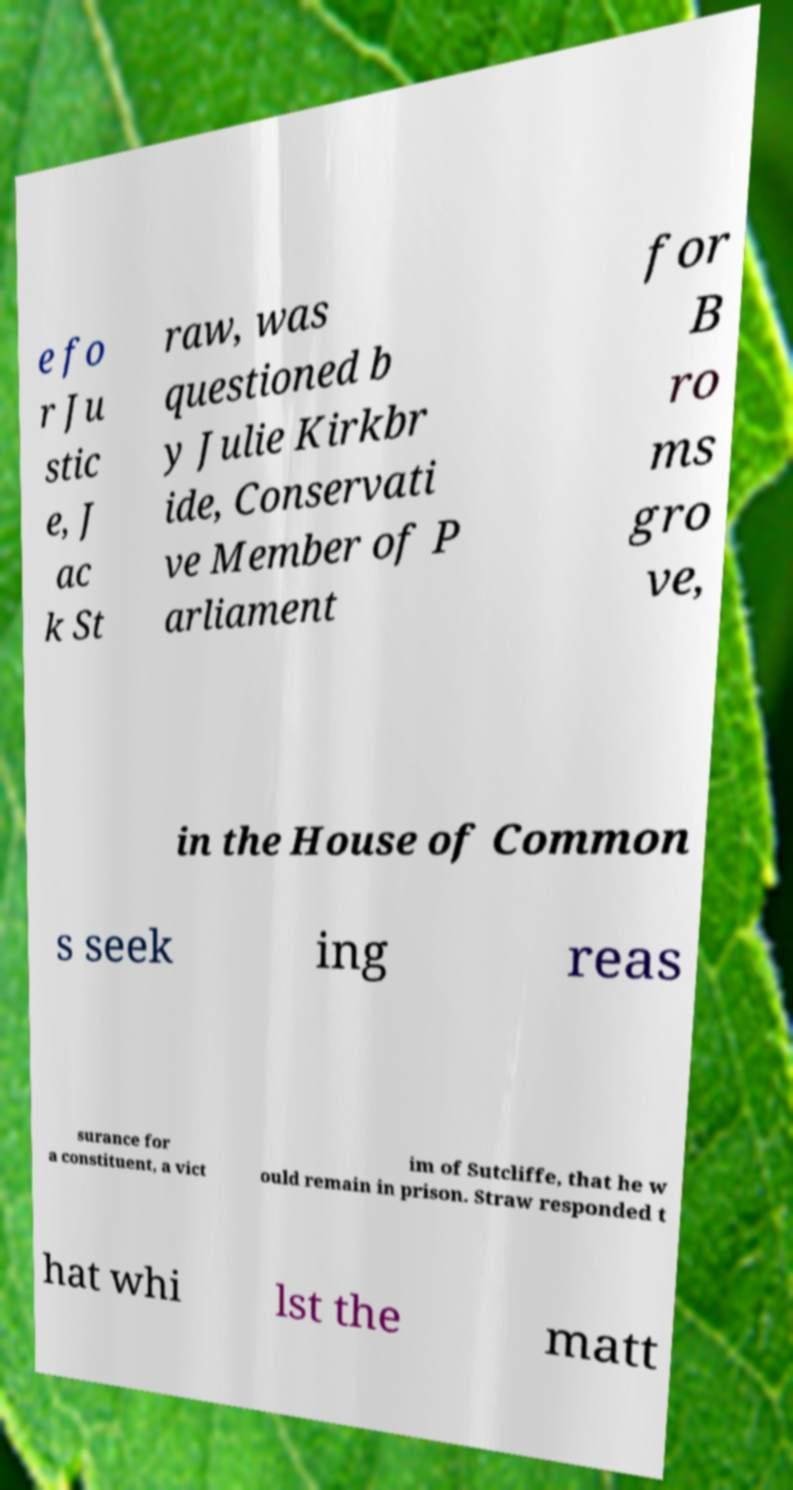Please read and relay the text visible in this image. What does it say? e fo r Ju stic e, J ac k St raw, was questioned b y Julie Kirkbr ide, Conservati ve Member of P arliament for B ro ms gro ve, in the House of Common s seek ing reas surance for a constituent, a vict im of Sutcliffe, that he w ould remain in prison. Straw responded t hat whi lst the matt 